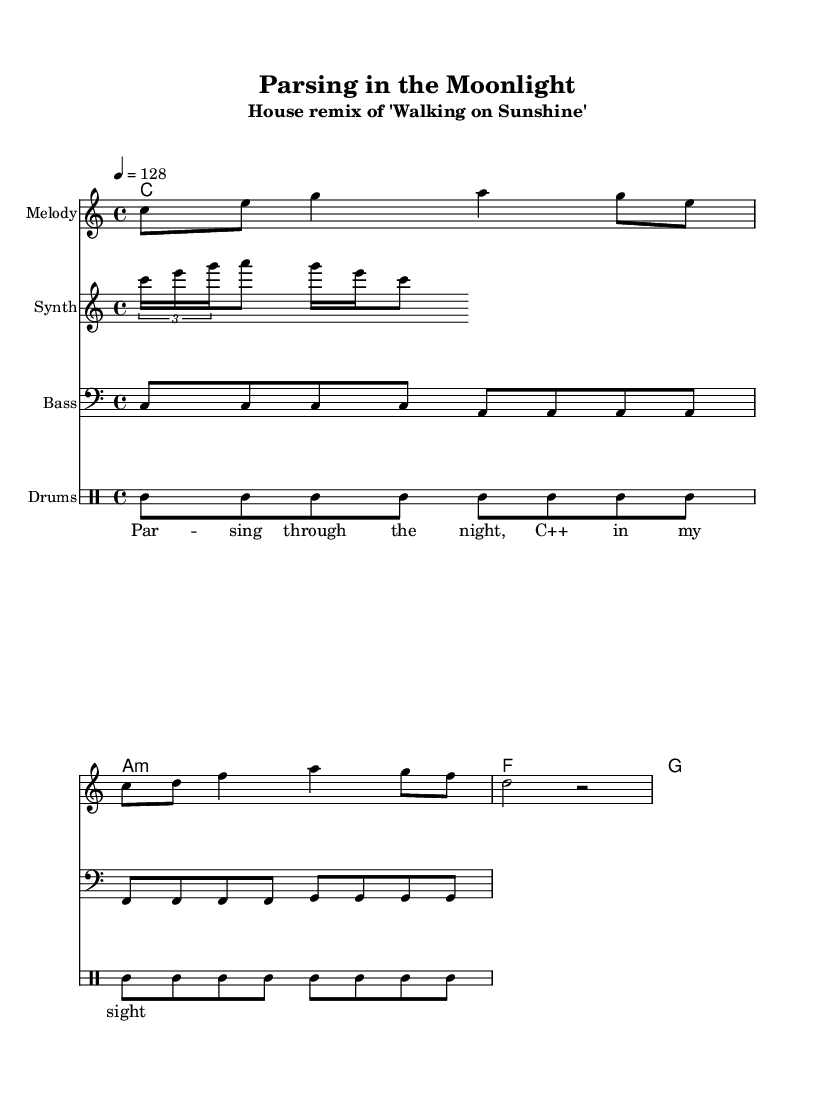What is the key signature of this music? The key signature is indicated at the beginning of the music and shows that there are no sharps or flats, which is characteristic of C major.
Answer: C major What is the time signature of this piece? The time signature is shown at the start of the music; it is 4/4, meaning there are four beats per measure and a quarter note gets one beat.
Answer: 4/4 What is the tempo marking for this piece? The tempo marking specifies that the music should be played at a speed of 128 beats per minute, which indicates a moderate pace for a house track.
Answer: 128 Which instrument plays the synth lead? The instrument that plays the synth lead is labeled in the score, specifically under "Synth," which indicates that the notes are meant for a synthesizer.
Answer: Synth How many measures are there in the melody? To find the number of measures, we count the distinct segments between the bar lines; the melody contains four measures based on the notated music.
Answer: 4 What is the chord progression for the harmony? The chord progression is visible in the chord names section, showing the sequence c, a minor, f, and g. This outlines the harmonic structure of the piece.
Answer: c, a minor, f, g What rhythmic pattern do the drums follow? The drum part can be observed in the drum staff, where the pattern shows bass drum and snare placements in a repeated rhythmic structure typical in house music.
Answer: Bass and snare pattern 